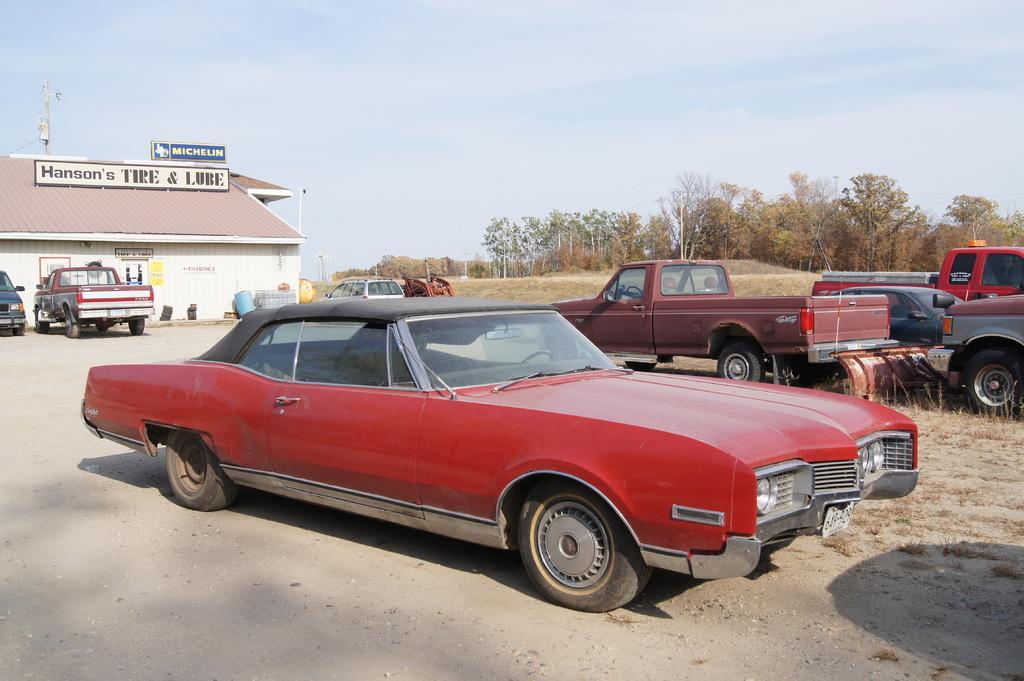Please provide a concise description of this image. In this picture I can see there is a red color car here and there are few other cars on to right and there are few other cars in the backdrop and there is a building in the backdrop, there are trees and the sky is clear. 